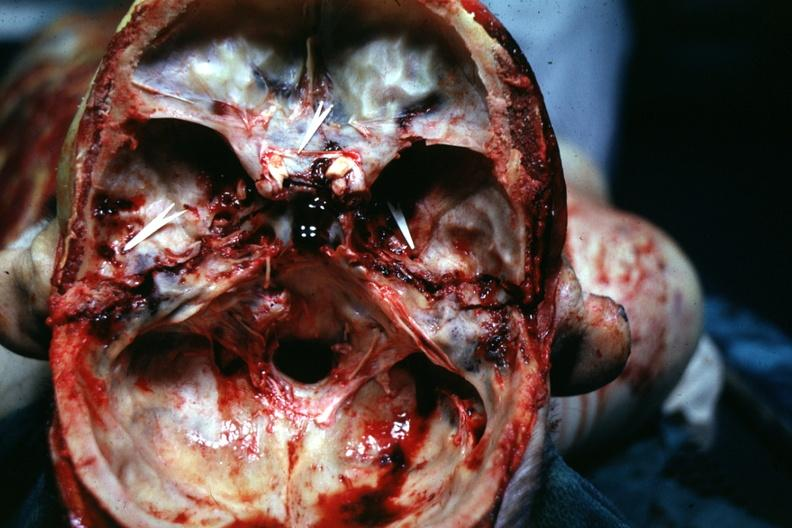does peritoneum show bilateral?
Answer the question using a single word or phrase. No 